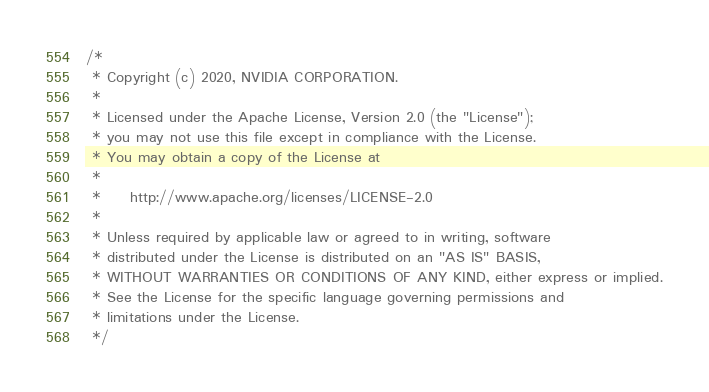Convert code to text. <code><loc_0><loc_0><loc_500><loc_500><_Cuda_>/*
 * Copyright (c) 2020, NVIDIA CORPORATION.
 *
 * Licensed under the Apache License, Version 2.0 (the "License");
 * you may not use this file except in compliance with the License.
 * You may obtain a copy of the License at
 *
 *     http://www.apache.org/licenses/LICENSE-2.0
 *
 * Unless required by applicable law or agreed to in writing, software
 * distributed under the License is distributed on an "AS IS" BASIS,
 * WITHOUT WARRANTIES OR CONDITIONS OF ANY KIND, either express or implied.
 * See the License for the specific language governing permissions and
 * limitations under the License.
 */
</code> 